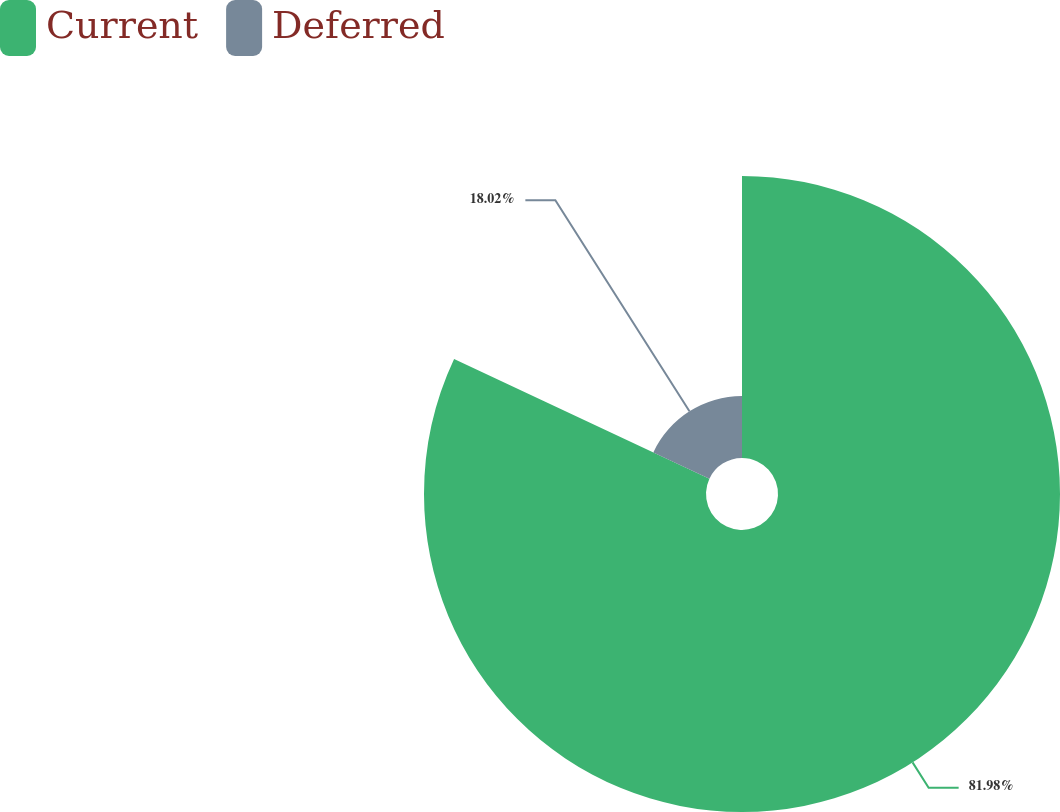Convert chart. <chart><loc_0><loc_0><loc_500><loc_500><pie_chart><fcel>Current<fcel>Deferred<nl><fcel>81.98%<fcel>18.02%<nl></chart> 